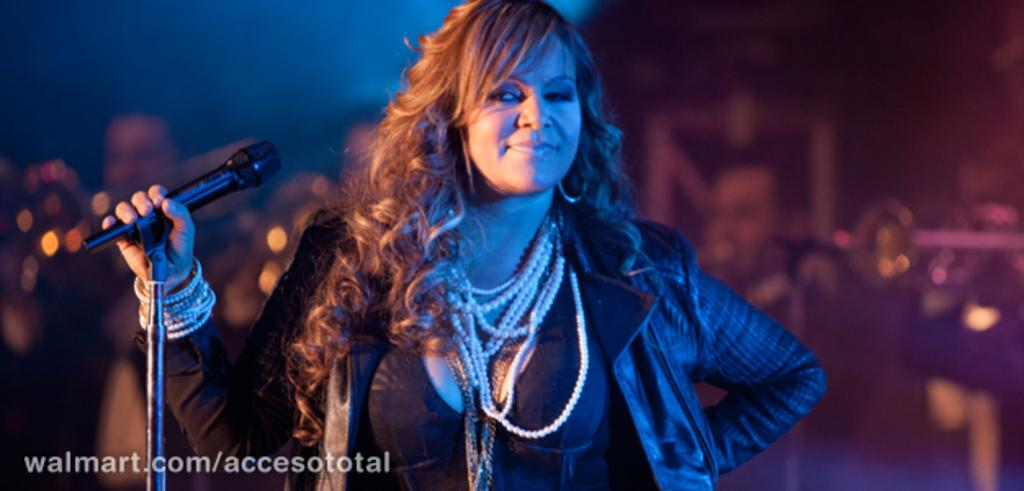What is the expression on the woman's face in the image? The woman in the image is smiling. What type of clothing is the woman wearing? The woman is wearing a jacket. What type of jewelry is the woman wearing? The woman is wearing pearl jewelry. What object is the woman holding in the image? The woman is holding a mic with a holder. Is there a pocket on the woman's jacket in the image? The provided facts do not mention a pocket on the woman's jacket, so it cannot be determined from the image. 